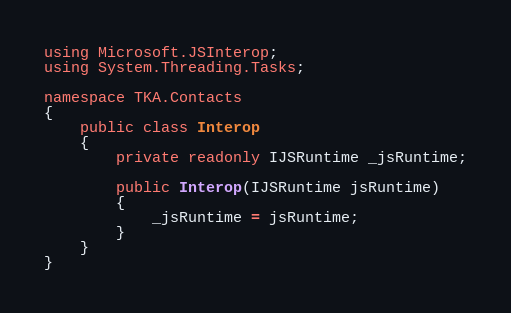<code> <loc_0><loc_0><loc_500><loc_500><_C#_>using Microsoft.JSInterop;
using System.Threading.Tasks;

namespace TKA.Contacts
{
    public class Interop
    {
        private readonly IJSRuntime _jsRuntime;

        public Interop(IJSRuntime jsRuntime)
        {
            _jsRuntime = jsRuntime;
        }
    }
}
</code> 